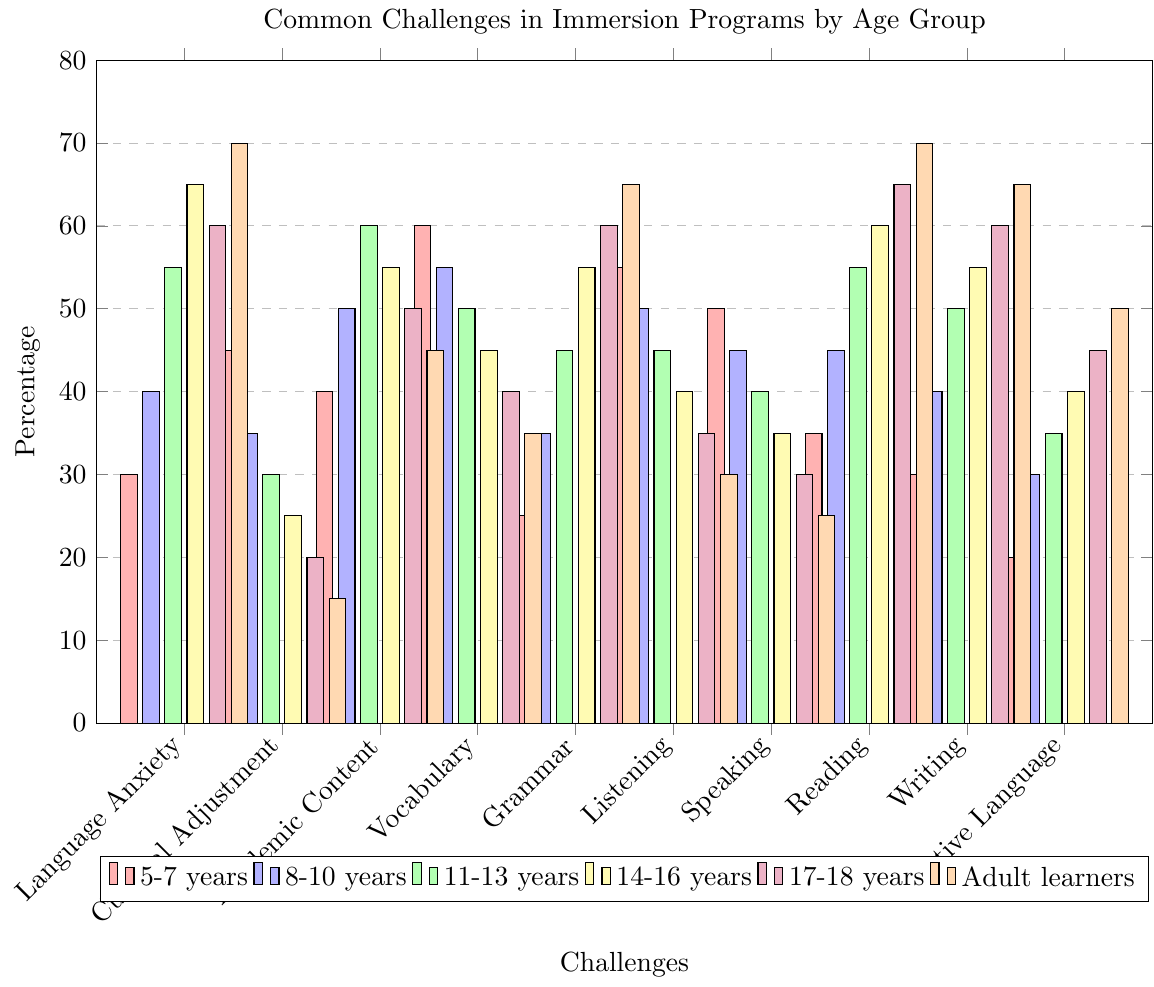What is the title of the figure? The title is usually displayed at the top of the figure. In this case, the provided rendering code generates the title "Common Challenges in Immersion Programs by Age Group." This can be read directly from the figure.
Answer: Common Challenges in Immersion Programs by Age Group What percentage of Language Anxiety is experienced by Adult learners? Locate the bar corresponding to "Language Anxiety" for Adult learners, which is color-coded as orange. The bar reaches up to 70%.
Answer: 70% Which age group experiences the highest percentage of Writing Skills challenges? Compare the bars for "Writing Skills" across all age groups. The tallest bar belongs to Adult learners, indicating the highest percentage.
Answer: Adult learners What is the difference in Listening Comprehension challenges between 5-7 years and Adult learners? The percentage for Listening Comprehension in 5-7 years is 55%, and for Adult learners, it's 30%. Subtract 30 from 55 to find the difference.
Answer: 25% How does the percentage of Grammar Mastery challenges change from 8-10 years to 17-18 years? Check the values for "Grammar Mastery" at both age groups: 35% for 8-10 years and 60% for 17-18 years. The percentage increases by 25%.
Answer: Increases by 25% Which challenge has the least percentage for 14-16 years? Identify the shortest bar for 14-16 years. The "Cultural Adjustment" bar is the shortest with 25%.
Answer: Cultural Adjustment What is the average percentage of Academic Content Comprehension challenges across all age groups? Sum up the values for "Academic Content Comprehension" across all age groups: 40% (5-7), 50% (8-10), 60% (11-13), 55% (14-16), 50% (17-18), 45% (Adult). The total is 300%, divide by 6 age groups.
Answer: 50% Which age group faces more challenges in Speaking Fluency compared to Maintaining Native Language? Compare the bars for "Speaking Fluency" and "Maintaining Native Language" for each age group. For 8-10 years and 11-13 years, "Speaking Fluency" is higher, but the trend varies by age group.
Answer: 8-10 years and 11-13 years How does the percentage of Cultural Adjustment challenges evolve from 5-7 years to Adult learners? Analyze the values for "Cultural Adjustment": 45% (5-7), 35% (8-10), 30% (11-13), 25% (14-16), 20% (17-18), and 15% (Adult). It decreases over time.
Answer: Decreases Which age group has the highest challenges in Reading Comprehension? Locate the tallest bar for "Reading Comprehension", which is for Adult learners with 70%.
Answer: Adult learners 